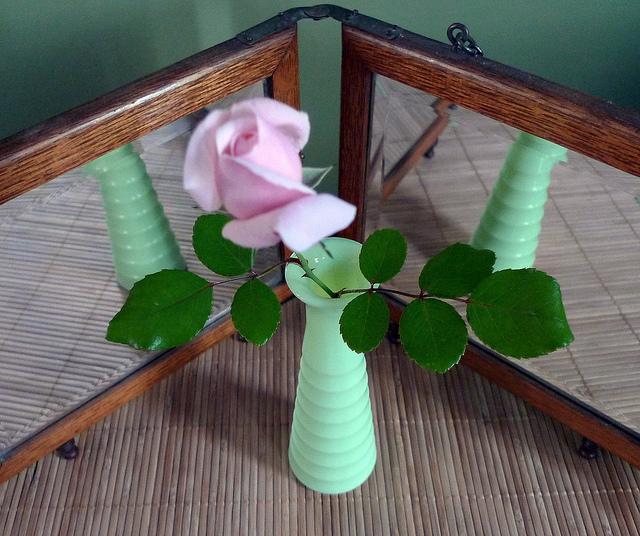How many mirrors are there?
Give a very brief answer. 2. How many giraffe heads can you see?
Give a very brief answer. 0. 